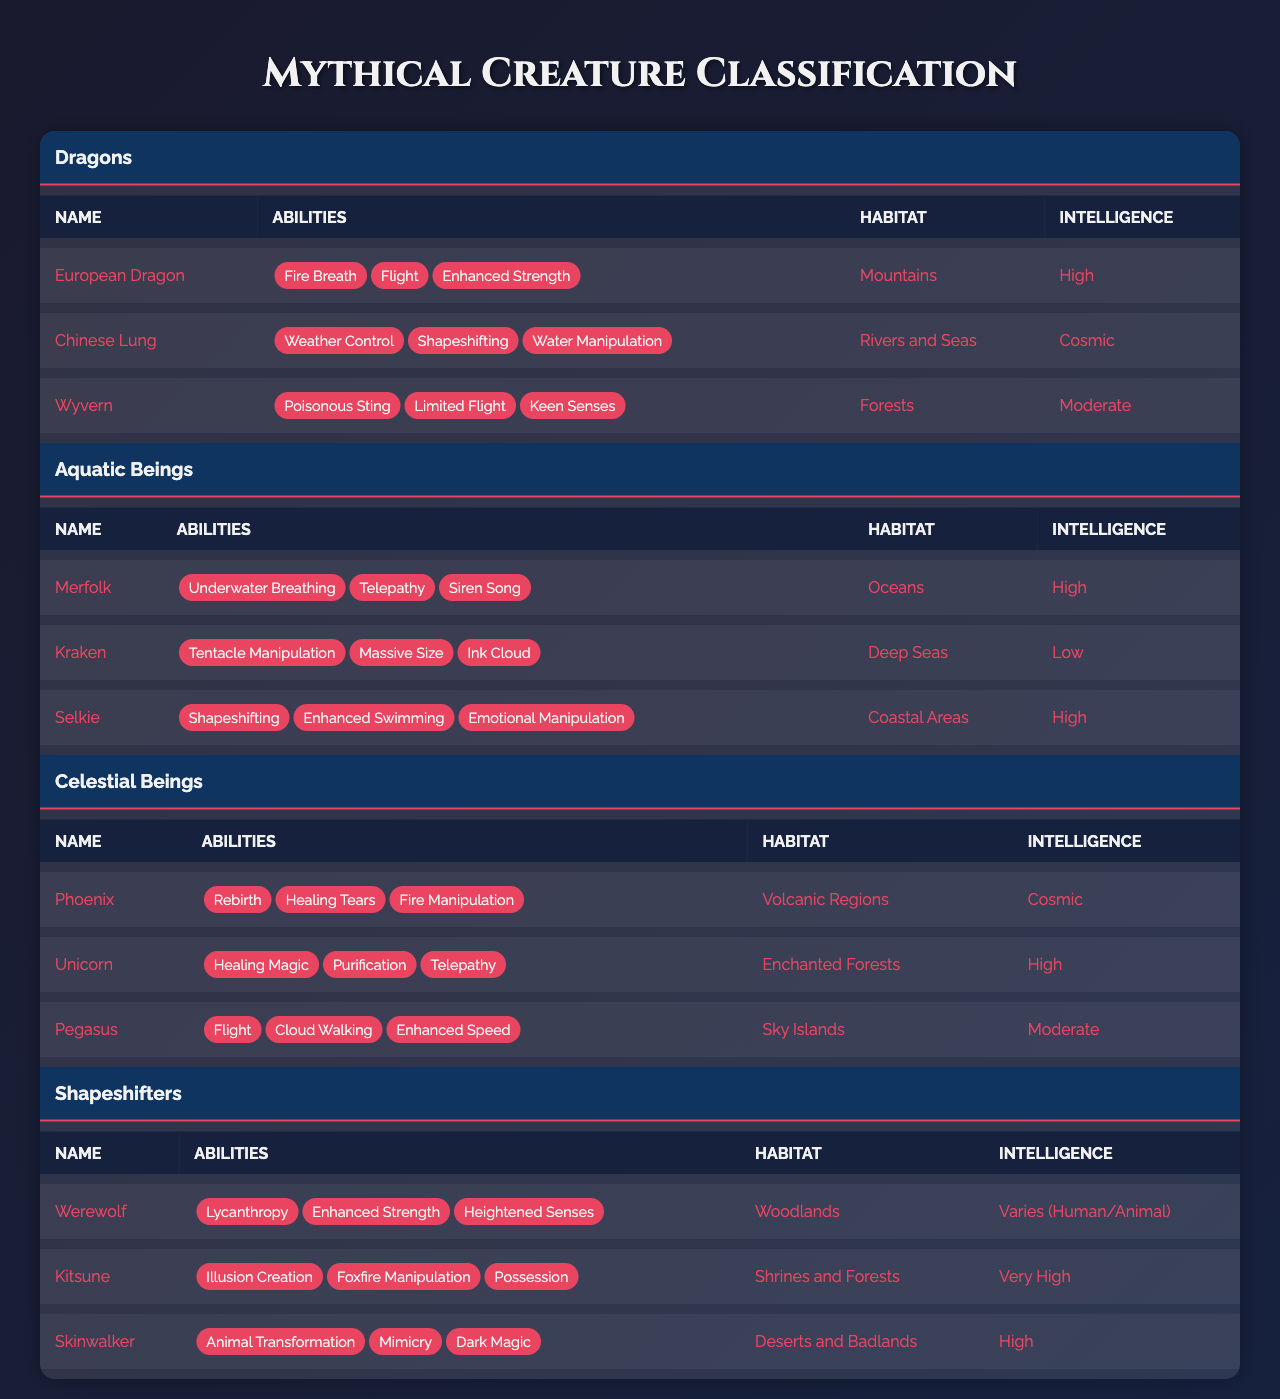What are the types of abilities possessed by the Chinese Lung? The table indicates the abilities of the Chinese Lung as "Weather Control," "Shapeshifting," and "Water Manipulation." These abilities are enumerated under the respective creature's entry.
Answer: Weather Control, Shapeshifting, Water Manipulation Which creature has the highest intelligence level? By reviewing the intelligence levels of all creatures, the Chinese Lung and the Phoenix are both marked as "Cosmic," which is the highest rating. Therefore, they share this distinction.
Answer: Chinese Lung and Phoenix How many types of abilities does the Wyvern have? The Wyvern's entry lists three specific abilities: "Poisonous Sting," "Limited Flight," and "Keen Senses." Thus, the total number of abilities is three.
Answer: 3 Do all creatures in the "Aquatic Beings" category have high intelligence? The intelligence levels of the Aquatic Beings are as follows: Merfolk (High), Kraken (Low), Selkie (High). Since the Kraken has a Low intelligence level, not all creatures in this category have high intelligence.
Answer: No Which creature's habitat is identified as "Coastal Areas"? The Selkie is the only creature listed under the "Aquatic Beings" category that has "Coastal Areas" as its habitat according to the table.
Answer: Selkie How many creatures in total possess the ability of Shapeshifting? In the table, both the Chinese Lung and the Selkie from the "Mythical Creatures" category possess Shapeshifting abilities, as well as the Kitsune under Shapeshifters. Therefore, there are three creatures with this ability.
Answer: 3 Which category contains the creature known for its ability to manipulate fire? There are two creatures in the table noted for their fire manipulation abilities: the European Dragon and the Phoenix, both of which belong to the Dragons and Celestial Beings categories, respectively.
Answer: Dragons and Celestial Beings How do the habitats of the Werewolf and the Kitsune differ? The Werewolf's habitat is located in "Woodlands," while the Kitsune's habitat is primarily "Shrines and Forests." Hence, the two habitats differ based on their specific descriptions even though they share some similarities.
Answer: They differ in specific descriptions (Woodlands vs. Shrines and Forests) Which types of creatures share the ability of flight? From the table, the creatures that possess the ability of flight are the European Dragon, Wyvern (under Dragons), Pegasus (under Celestial Beings), indicating that four creatures have this ability when counting the translation from multiple categories.
Answer: 4 Does any creature with a "High" intelligence level also have the ability "Emotional Manipulation"? The table confirms that the Selkie, which has a "High" intelligence level, possesses the ability "Emotional Manipulation." Thus, there is at least one creature satisfying this condition.
Answer: Yes 